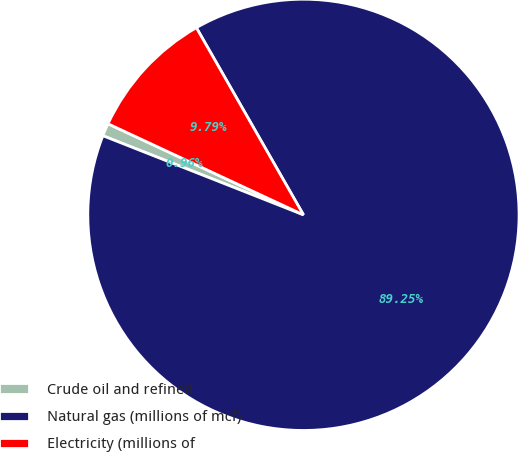Convert chart. <chart><loc_0><loc_0><loc_500><loc_500><pie_chart><fcel>Crude oil and refined<fcel>Natural gas (millions of mcf)<fcel>Electricity (millions of<nl><fcel>0.96%<fcel>89.26%<fcel>9.79%<nl></chart> 